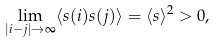<formula> <loc_0><loc_0><loc_500><loc_500>\lim _ { | i - j | \rightarrow \infty } \langle s ( i ) s ( j ) \rangle = \langle s \rangle ^ { 2 } > 0 ,</formula> 